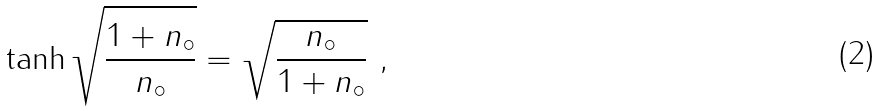Convert formula to latex. <formula><loc_0><loc_0><loc_500><loc_500>\tanh \sqrt { \frac { 1 + n _ { \circ } } { n _ { \circ } } } = \sqrt { \frac { n _ { \circ } } { 1 + n _ { \circ } } } \ ,</formula> 